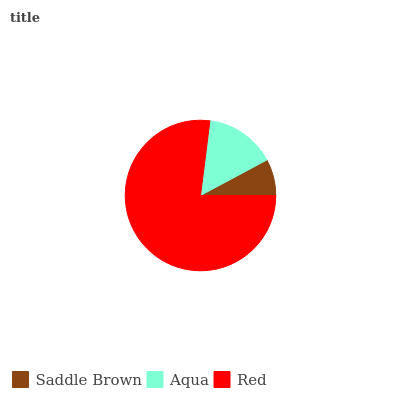Is Saddle Brown the minimum?
Answer yes or no. Yes. Is Red the maximum?
Answer yes or no. Yes. Is Aqua the minimum?
Answer yes or no. No. Is Aqua the maximum?
Answer yes or no. No. Is Aqua greater than Saddle Brown?
Answer yes or no. Yes. Is Saddle Brown less than Aqua?
Answer yes or no. Yes. Is Saddle Brown greater than Aqua?
Answer yes or no. No. Is Aqua less than Saddle Brown?
Answer yes or no. No. Is Aqua the high median?
Answer yes or no. Yes. Is Aqua the low median?
Answer yes or no. Yes. Is Saddle Brown the high median?
Answer yes or no. No. Is Saddle Brown the low median?
Answer yes or no. No. 